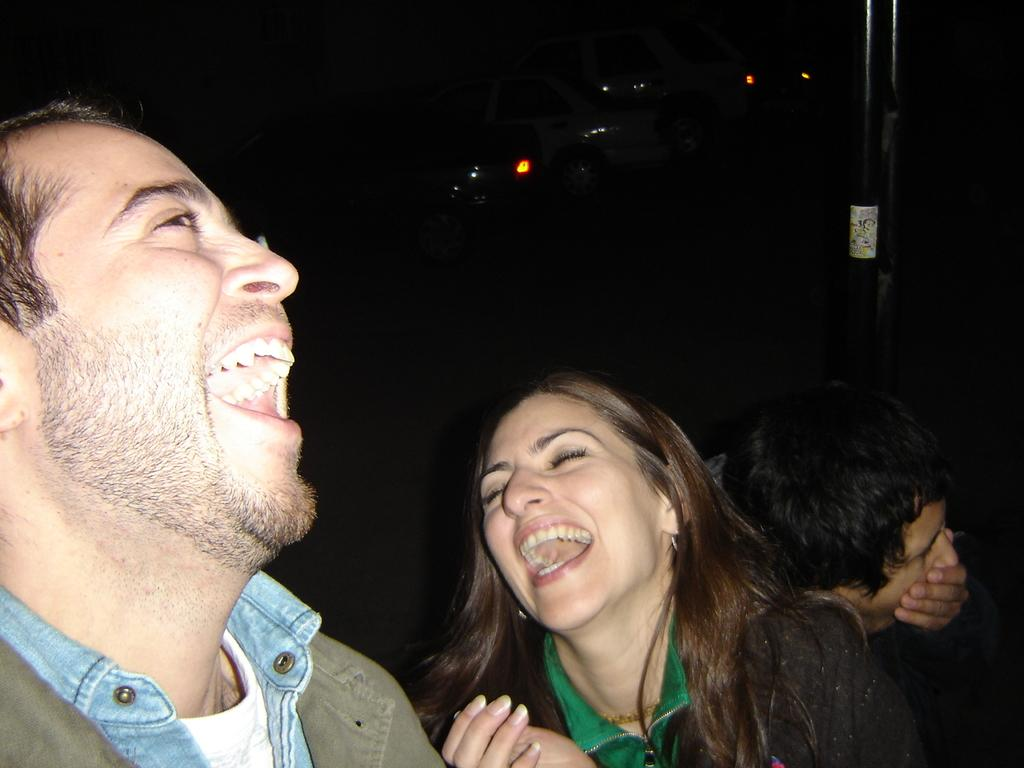Who is present in the image? There are people in the image. What are the people doing in the image? The people are laughing. What can be seen in the background of the image? There is a pole and vehicles visible in the background of the image. What type of squirrel can be seen running on the ground in the image? There is no squirrel running on the ground in the image. 